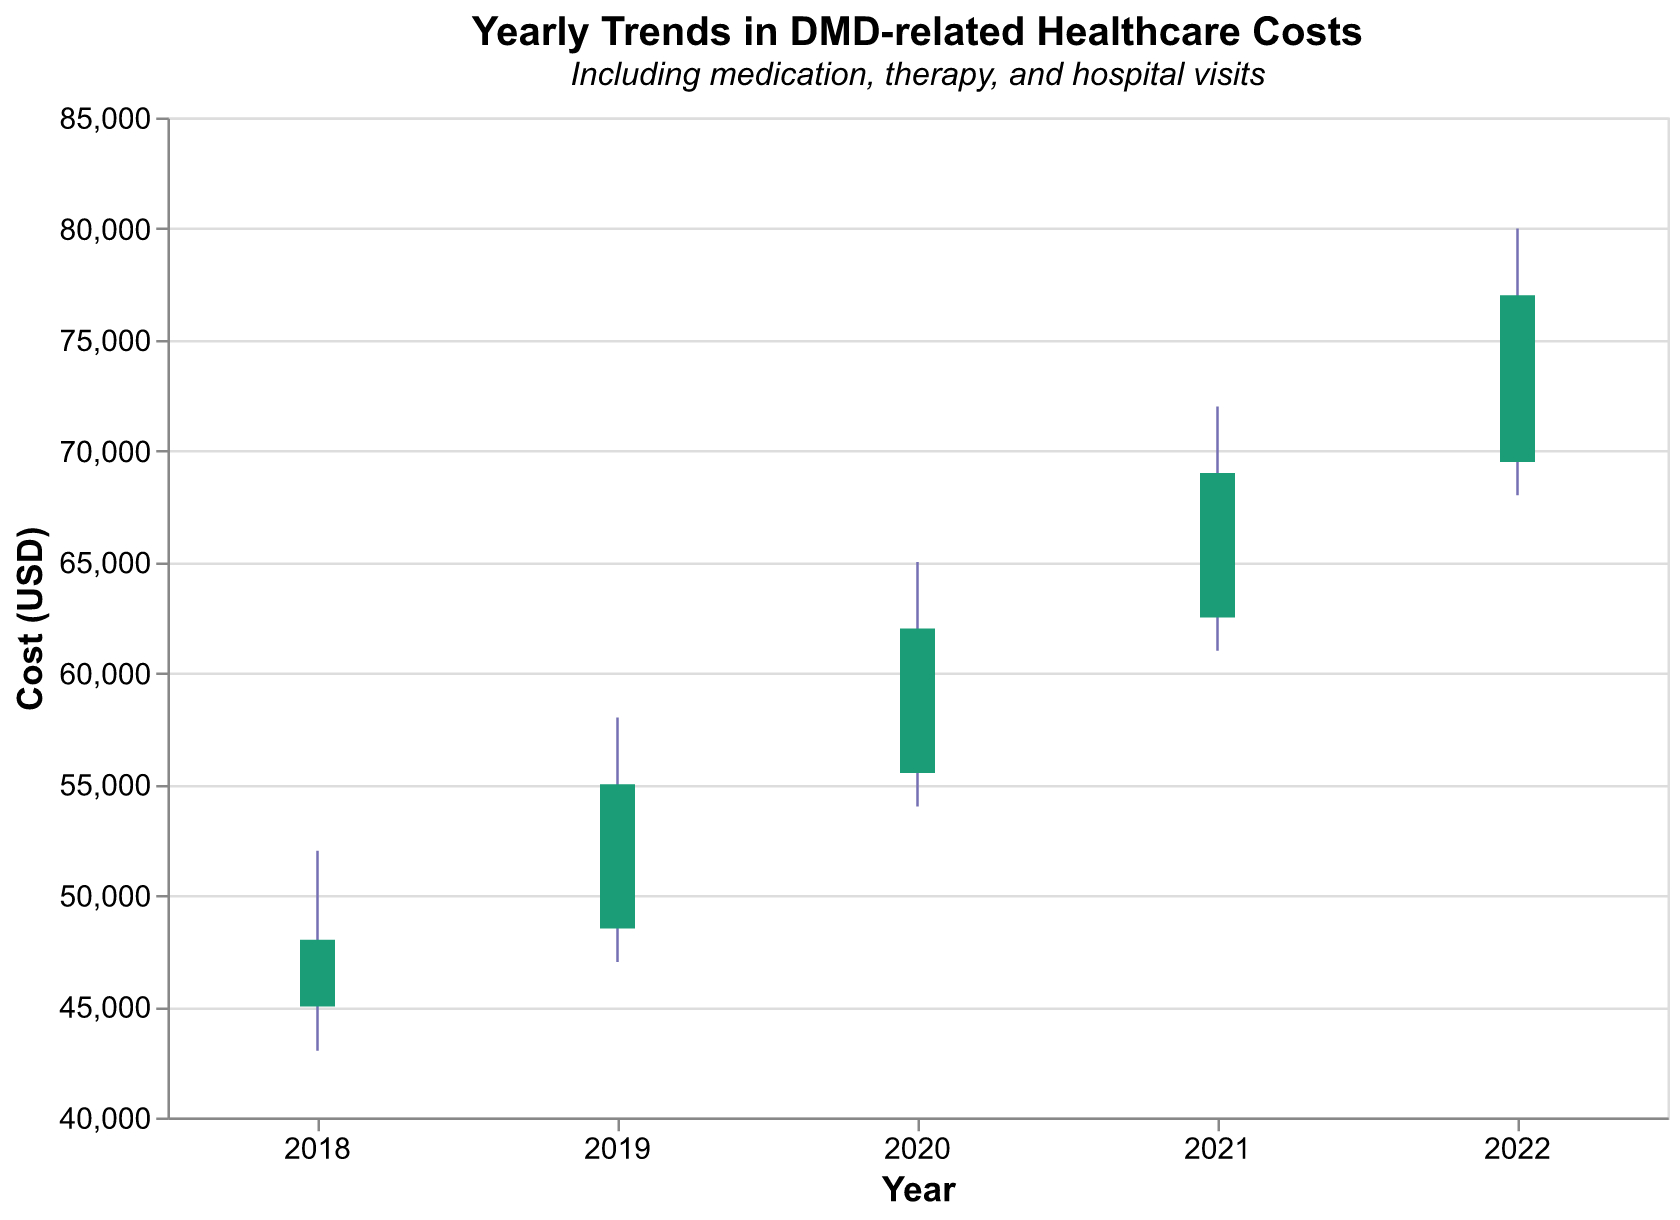What is the title of the chart? The title of the chart can be found at the top of the figure. It usually summarizes the main topic of the visualization.
Answer: Yearly Trends in DMD-related Healthcare Costs What is the subtitle of the chart? The subtitle is a secondary title providing additional context. It is typically placed below the main title.
Answer: Including medication, therapy, and hospital visits What is the highest healthcare cost recorded in the chart, and in which year did it occur? To find the highest healthcare cost, look at the "High" values and identify the maximum. The highest value is \$80,000 in the year 2022.
Answer: \$80,000 in 2022 By how much did the closing cost increase from 2018 to 2022? Calculate the difference between the closing costs in 2022 and 2018. The closing cost in 2022 is \$77,000 and in 2018 it is \$48,000. The increase is \$77,000 - \$48,000 = \$29,000.
Answer: \$29,000 Which year had the smallest range between the lowest and highest healthcare cost? Calculate the range for each year by subtracting the "Low" value from the "High" value. The smallest range is in 2018, where the range is \$52,000 - \$43,000 = \$9,000.
Answer: 2018 How did the highest cost in 2021 compare to the highest cost in 2020? Compare the "High" values for both years. The highest cost in 2021 is \$72,000, and in 2020 it is \$65,000. Thus, the highest cost increased by \$72,000 - \$65,000 = \$7,000.
Answer: Increased by \$7,000 Was there any year where the closing cost was lower than the opening cost? If so, which year and by how much did it decrease? Check if the "Close" value is lower than the "Open" value in any year. In 2018, the closing cost (\$48,000) was lower than the opening cost (\$45,000). The decrease was \$45,000 - \$48,000 = \$3,000.
Answer: 2018, decreased by \$3,000 What is the trend in the opening costs from 2018 to 2022? Assess the opening costs for each year: \$45,000 (2018), \$48,500 (2019), \$55,500 (2020), \$62,500 (2021), and \$69,500 (2022). The opening costs show an increasing trend over the years.
Answer: Increasing trend Determine the average closing cost over the five years. Add up all the closing costs and divide by the number of years. The closing costs are \$48,000 (2018), \$55,000 (2019), \$62,000 (2020), \$69,000 (2021), and \$77,000 (2022). The sum is \$48,000 + \$55,000 + \$62,000 + \$69,000 + \$77,000 = \$311,000. The average is \$311,000 / 5 = \$62,200.
Answer: \$62,200 If the trend in closing costs observed continues, predict the closing cost for 2023. Derive the annual increase in closing costs using the previous years: (2019: +\$7,000, 2020: +\$7,000, 2021: +\$7,000, 2022: +\$8,000). The average annual increase: (\$7,000 + \$7,000 + \$7,000 + \$8,000) / 4 = \$7,250. Predict 2023's closing cost by adding 2022's closing cost to the average increase: \$77,000 + \$7,250 = \$84,250.
Answer: \$84,250 